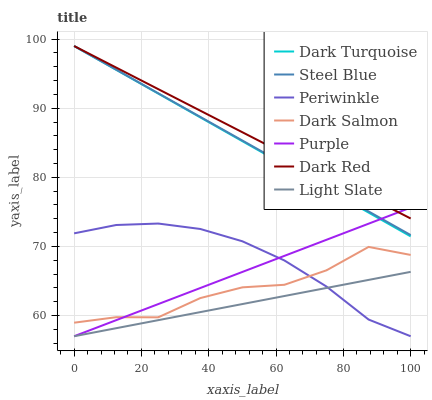Does Light Slate have the minimum area under the curve?
Answer yes or no. Yes. Does Dark Red have the maximum area under the curve?
Answer yes or no. Yes. Does Dark Turquoise have the minimum area under the curve?
Answer yes or no. No. Does Dark Turquoise have the maximum area under the curve?
Answer yes or no. No. Is Light Slate the smoothest?
Answer yes or no. Yes. Is Dark Salmon the roughest?
Answer yes or no. Yes. Is Dark Turquoise the smoothest?
Answer yes or no. No. Is Dark Turquoise the roughest?
Answer yes or no. No. Does Purple have the lowest value?
Answer yes or no. Yes. Does Dark Turquoise have the lowest value?
Answer yes or no. No. Does Dark Red have the highest value?
Answer yes or no. Yes. Does Dark Salmon have the highest value?
Answer yes or no. No. Is Dark Salmon less than Steel Blue?
Answer yes or no. Yes. Is Dark Turquoise greater than Periwinkle?
Answer yes or no. Yes. Does Purple intersect Dark Salmon?
Answer yes or no. Yes. Is Purple less than Dark Salmon?
Answer yes or no. No. Is Purple greater than Dark Salmon?
Answer yes or no. No. Does Dark Salmon intersect Steel Blue?
Answer yes or no. No. 